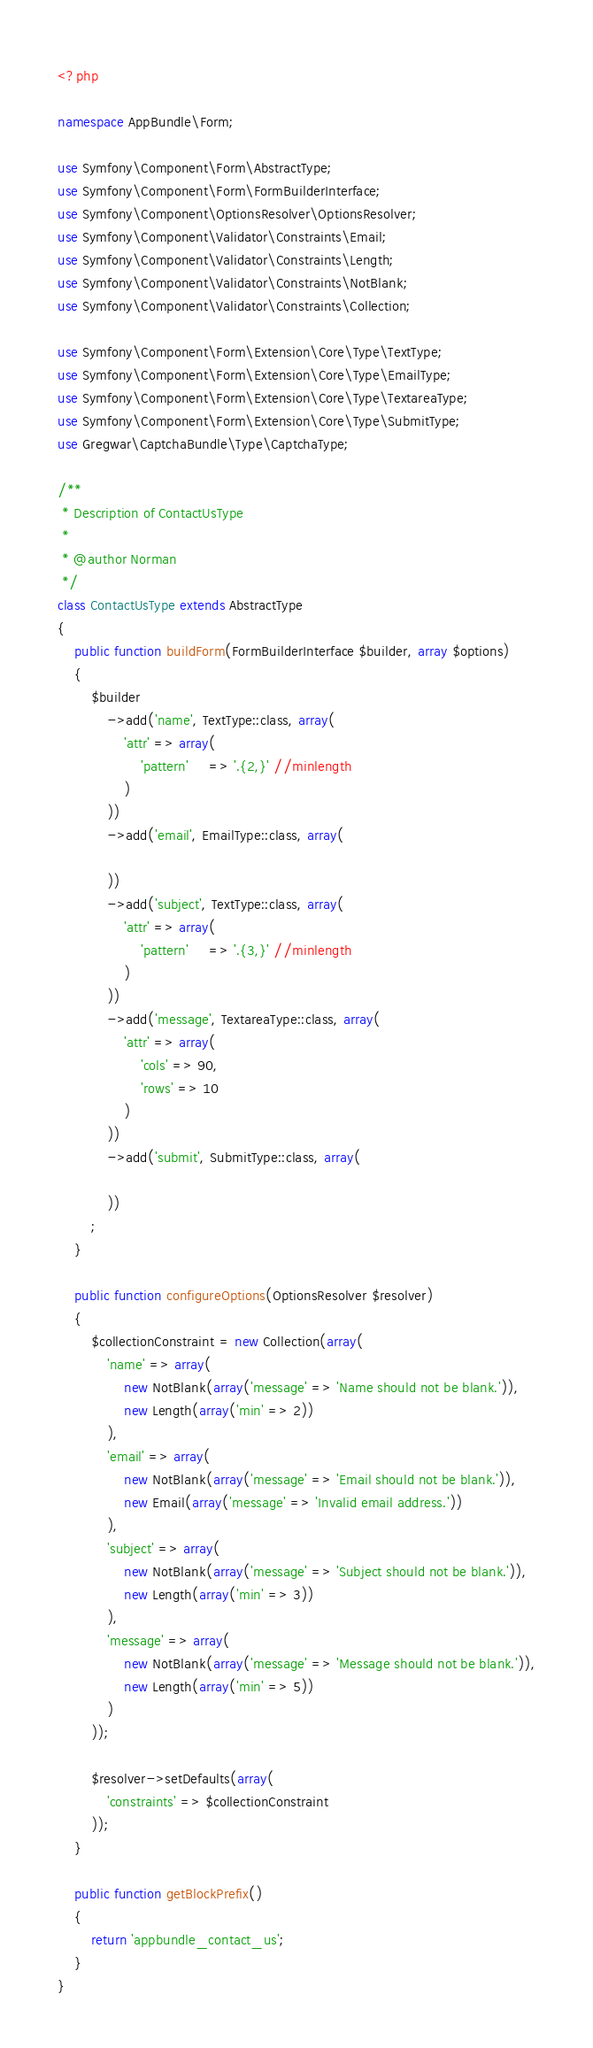Convert code to text. <code><loc_0><loc_0><loc_500><loc_500><_PHP_><?php

namespace AppBundle\Form;

use Symfony\Component\Form\AbstractType;
use Symfony\Component\Form\FormBuilderInterface;
use Symfony\Component\OptionsResolver\OptionsResolver;
use Symfony\Component\Validator\Constraints\Email;
use Symfony\Component\Validator\Constraints\Length;
use Symfony\Component\Validator\Constraints\NotBlank;
use Symfony\Component\Validator\Constraints\Collection;

use Symfony\Component\Form\Extension\Core\Type\TextType;
use Symfony\Component\Form\Extension\Core\Type\EmailType;
use Symfony\Component\Form\Extension\Core\Type\TextareaType;
use Symfony\Component\Form\Extension\Core\Type\SubmitType;
use Gregwar\CaptchaBundle\Type\CaptchaType;

/**
 * Description of ContactUsType
 *
 * @author Norman
 */
class ContactUsType extends AbstractType
{
    public function buildForm(FormBuilderInterface $builder, array $options)
    {
        $builder
            ->add('name', TextType::class, array(
                'attr' => array(                    
                    'pattern'     => '.{2,}' //minlength
                )
            ))
            ->add('email', EmailType::class, array(
                
            ))
            ->add('subject', TextType::class, array(
                'attr' => array(                    
                    'pattern'     => '.{3,}' //minlength
                )
            ))
            ->add('message', TextareaType::class, array(
                'attr' => array(
                    'cols' => 90,
                    'rows' => 10
                )
            ))
            ->add('submit', SubmitType::class, array(

            ))
        ;
    }

    public function configureOptions(OptionsResolver $resolver)
    {
        $collectionConstraint = new Collection(array(
            'name' => array(
                new NotBlank(array('message' => 'Name should not be blank.')),
                new Length(array('min' => 2))
            ),
            'email' => array(
                new NotBlank(array('message' => 'Email should not be blank.')),
                new Email(array('message' => 'Invalid email address.'))
            ),
            'subject' => array(
                new NotBlank(array('message' => 'Subject should not be blank.')),
                new Length(array('min' => 3))
            ),
            'message' => array(
                new NotBlank(array('message' => 'Message should not be blank.')),
                new Length(array('min' => 5))
            )
        ));

        $resolver->setDefaults(array(
            'constraints' => $collectionConstraint
        ));
    }

    public function getBlockPrefix()
    {
        return 'appbundle_contact_us';
    }
}
</code> 